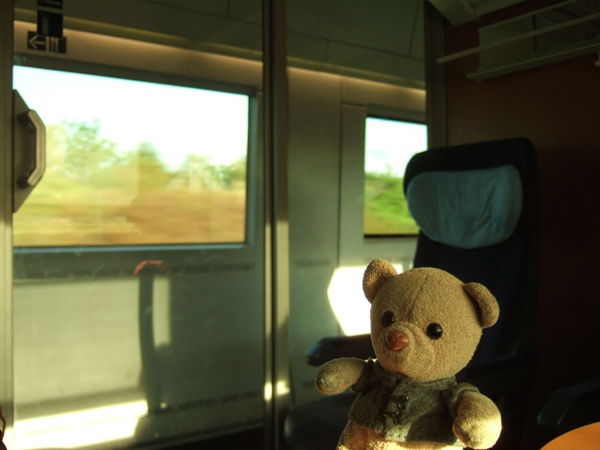Describe the objects in this image and their specific colors. I can see teddy bear in black, olive, and maroon tones and chair in black, olive, and teal tones in this image. 